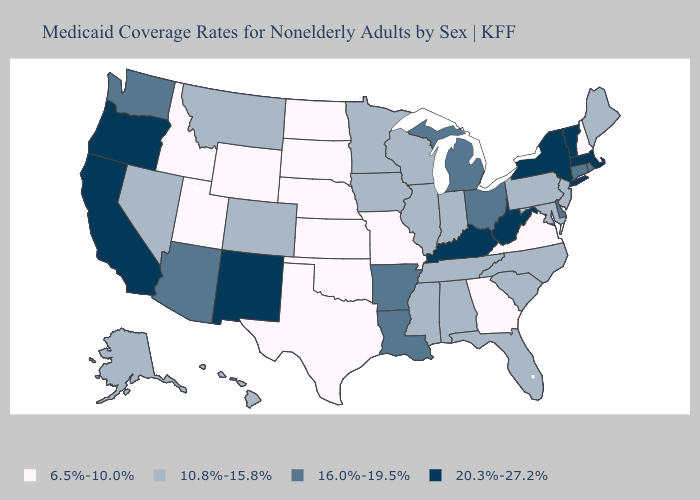Name the states that have a value in the range 20.3%-27.2%?
Give a very brief answer. California, Kentucky, Massachusetts, New Mexico, New York, Oregon, Vermont, West Virginia. Among the states that border Wisconsin , does Iowa have the highest value?
Give a very brief answer. No. Among the states that border Vermont , does New Hampshire have the lowest value?
Quick response, please. Yes. What is the value of Maryland?
Be succinct. 10.8%-15.8%. Name the states that have a value in the range 6.5%-10.0%?
Short answer required. Georgia, Idaho, Kansas, Missouri, Nebraska, New Hampshire, North Dakota, Oklahoma, South Dakota, Texas, Utah, Virginia, Wyoming. What is the lowest value in states that border Connecticut?
Answer briefly. 16.0%-19.5%. What is the value of Alaska?
Concise answer only. 10.8%-15.8%. Does the map have missing data?
Write a very short answer. No. What is the value of Alabama?
Concise answer only. 10.8%-15.8%. Name the states that have a value in the range 16.0%-19.5%?
Short answer required. Arizona, Arkansas, Connecticut, Delaware, Louisiana, Michigan, Ohio, Rhode Island, Washington. What is the value of Maine?
Be succinct. 10.8%-15.8%. Name the states that have a value in the range 6.5%-10.0%?
Write a very short answer. Georgia, Idaho, Kansas, Missouri, Nebraska, New Hampshire, North Dakota, Oklahoma, South Dakota, Texas, Utah, Virginia, Wyoming. Does Indiana have the lowest value in the USA?
Keep it brief. No. How many symbols are there in the legend?
Short answer required. 4. Does Nebraska have a lower value than New Hampshire?
Give a very brief answer. No. 